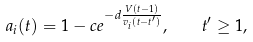Convert formula to latex. <formula><loc_0><loc_0><loc_500><loc_500>a _ { i } ( t ) = 1 - c e ^ { - d \frac { V ( t - 1 ) } { v _ { i } ( t - t ^ { \prime } ) } } , \quad t ^ { \prime } \geq 1 ,</formula> 